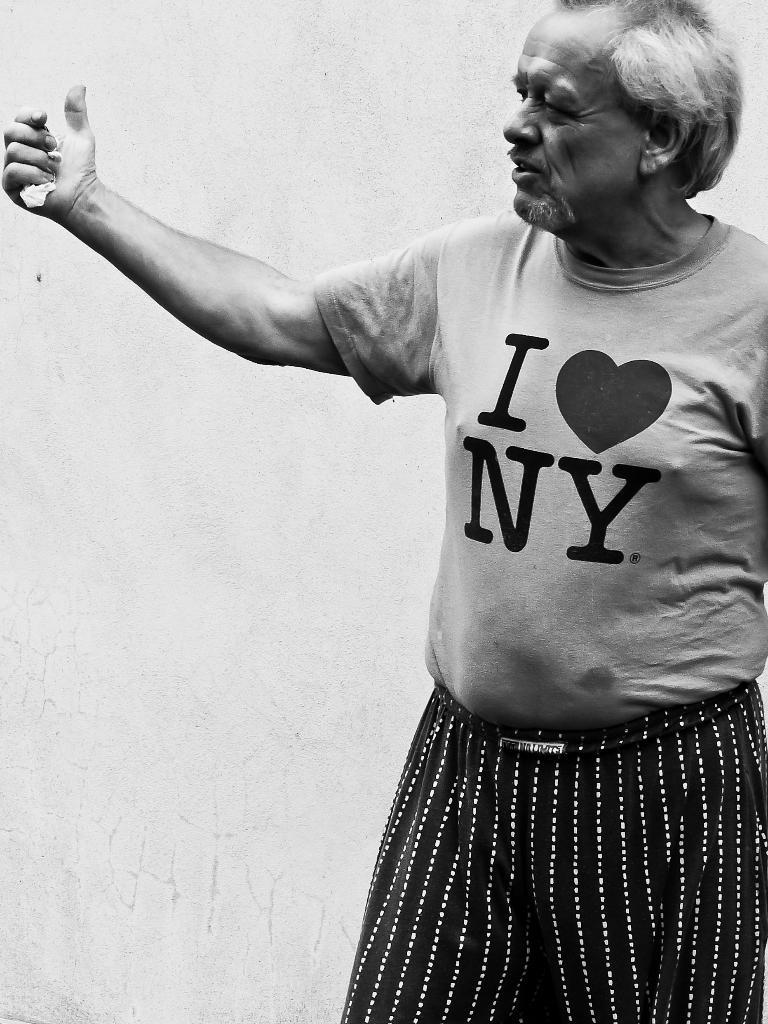Who is present in the image? There is a man in the image. What is the man doing in the image? The man is standing in the image. What is the man wearing in the image? The man is wearing a T-shirt in the image. What is the color scheme of the image? The image is black and white in color. What type of brake can be seen on the man's shoes in the image? There are no shoes or brakes visible in the image; it only features a man standing in a black and white setting. 